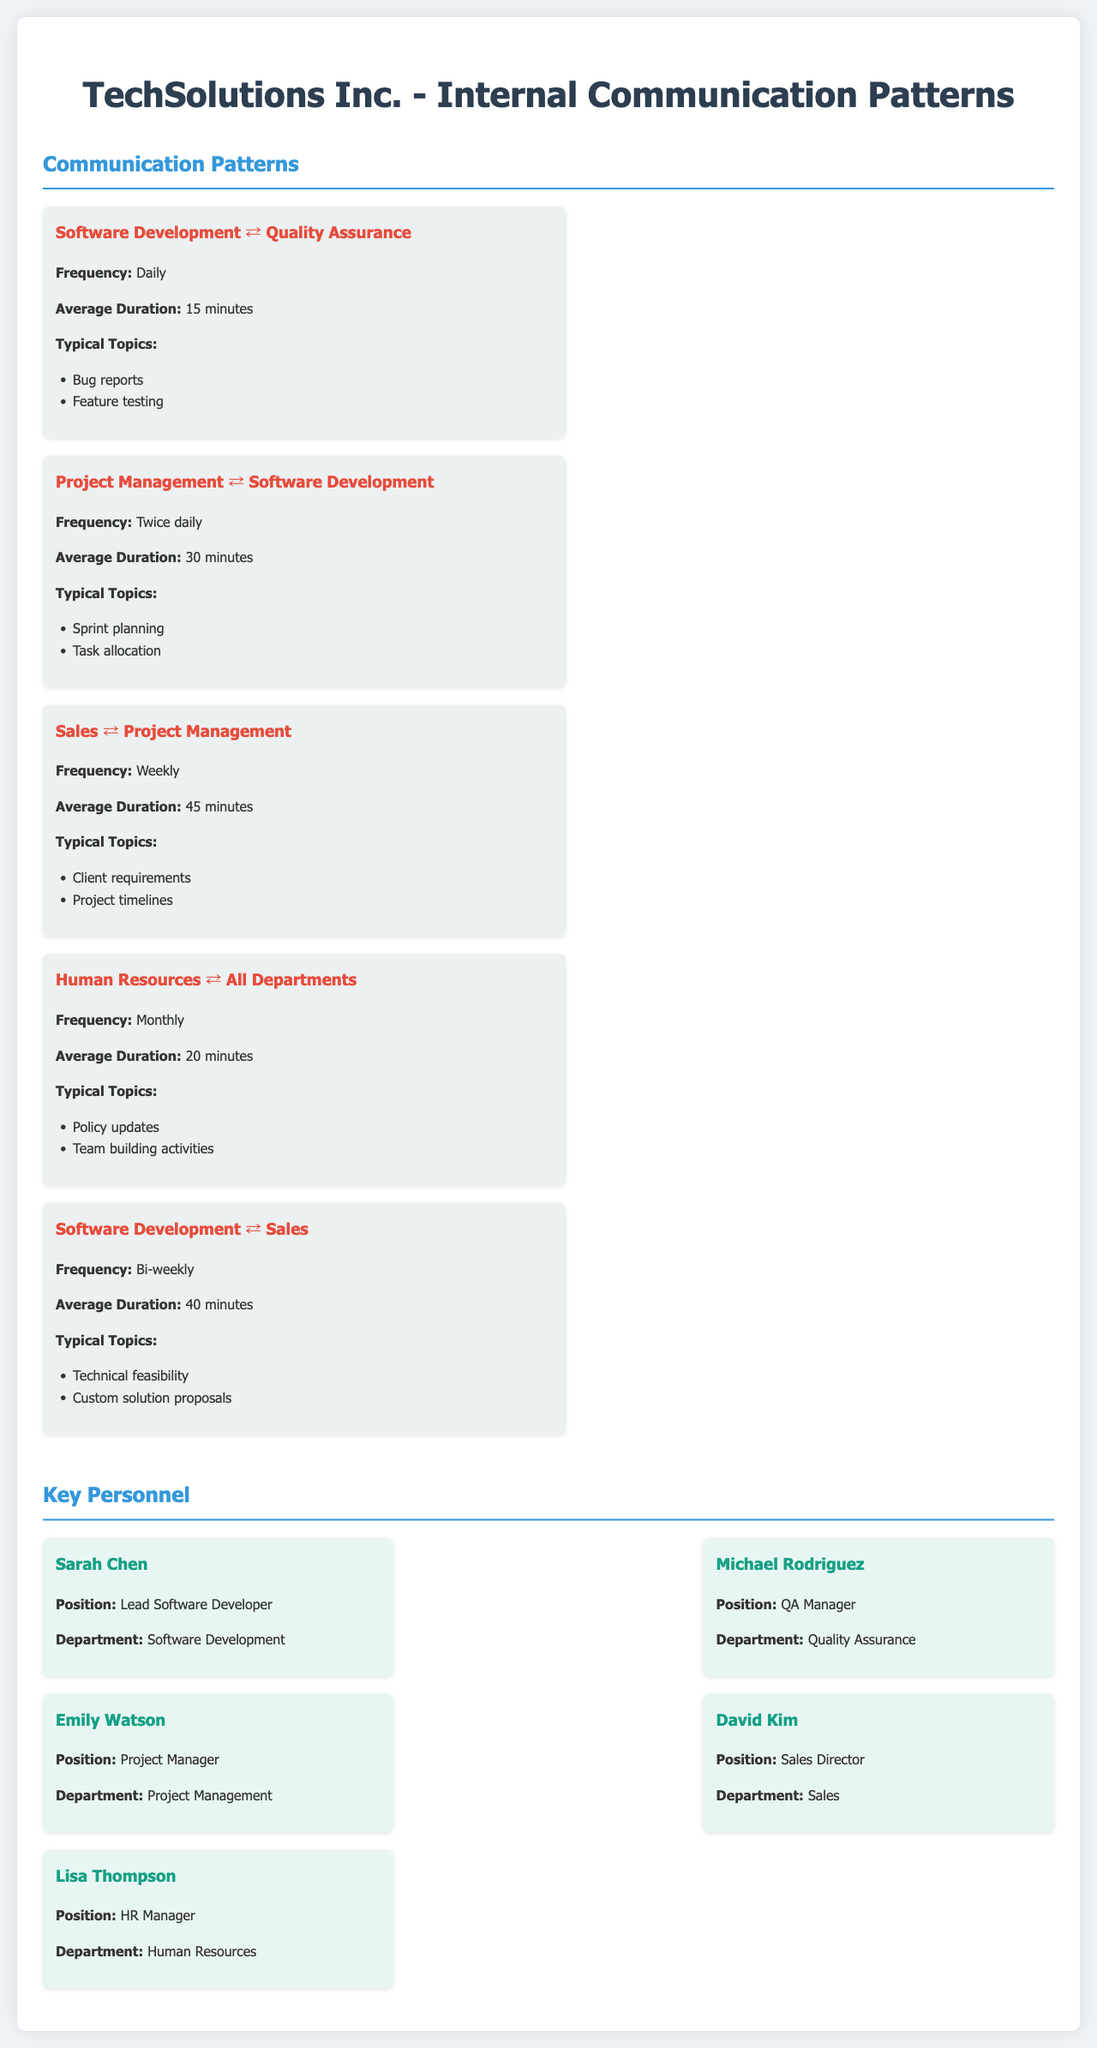What department communicates daily with Quality Assurance? The document states that Software Development communicates daily with Quality Assurance.
Answer: Software Development What is the average duration of calls between Project Management and Software Development? The document specifies that the average duration of calls between Project Management and Software Development is 30 minutes.
Answer: 30 minutes How often do Sales and Project Management communicate? The document indicates that Sales and Project Management communicate weekly.
Answer: Weekly What are the typical topics discussed between Software Development and Sales? The document lists technical feasibility and custom solution proposals as typical topics discussed between Software Development and Sales.
Answer: Technical feasibility, custom solution proposals Who is the QA Manager? The document names Michael Rodriguez as the QA Manager.
Answer: Michael Rodriguez What is the frequency of communication between Human Resources and all departments? The document mentions that Human Resources communicates with all departments monthly.
Answer: Monthly How many personnel are listed in the key personnel section? The document includes five key personnel members in the key personnel section.
Answer: Five What is the average duration of calls between Software Development and Quality Assurance? The document specifies that the average duration of calls between Software Development and Quality Assurance is 15 minutes.
Answer: 15 minutes Which department does Lisa Thompson manage? The document states that Lisa Thompson is the HR Manager.
Answer: Human Resources 